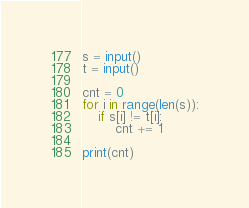<code> <loc_0><loc_0><loc_500><loc_500><_Python_>s = input()
t = input()

cnt = 0
for i in range(len(s)):
    if s[i] != t[i]:
        cnt += 1

print(cnt)</code> 